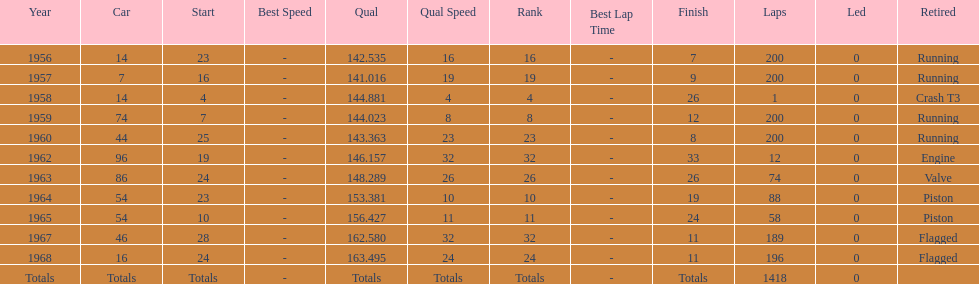Could you parse the entire table as a dict? {'header': ['Year', 'Car', 'Start', 'Best Speed', 'Qual', 'Qual Speed', 'Rank', 'Best Lap Time', 'Finish', 'Laps', 'Led', 'Retired'], 'rows': [['1956', '14', '23', '-', '142.535', '16', '16', '-', '7', '200', '0', 'Running'], ['1957', '7', '16', '-', '141.016', '19', '19', '-', '9', '200', '0', 'Running'], ['1958', '14', '4', '-', '144.881', '4', '4', '-', '26', '1', '0', 'Crash T3'], ['1959', '74', '7', '-', '144.023', '8', '8', '-', '12', '200', '0', 'Running'], ['1960', '44', '25', '-', '143.363', '23', '23', '-', '8', '200', '0', 'Running'], ['1962', '96', '19', '-', '146.157', '32', '32', '-', '33', '12', '0', 'Engine'], ['1963', '86', '24', '-', '148.289', '26', '26', '-', '26', '74', '0', 'Valve'], ['1964', '54', '23', '-', '153.381', '10', '10', '-', '19', '88', '0', 'Piston'], ['1965', '54', '10', '-', '156.427', '11', '11', '-', '24', '58', '0', 'Piston'], ['1967', '46', '28', '-', '162.580', '32', '32', '-', '11', '189', '0', 'Flagged'], ['1968', '16', '24', '-', '163.495', '24', '24', '-', '11', '196', '0', 'Flagged'], ['Totals', 'Totals', 'Totals', '-', 'Totals', 'Totals', 'Totals', '-', 'Totals', '1418', '0', '']]} What year did he have the same number car as 1964? 1965. 